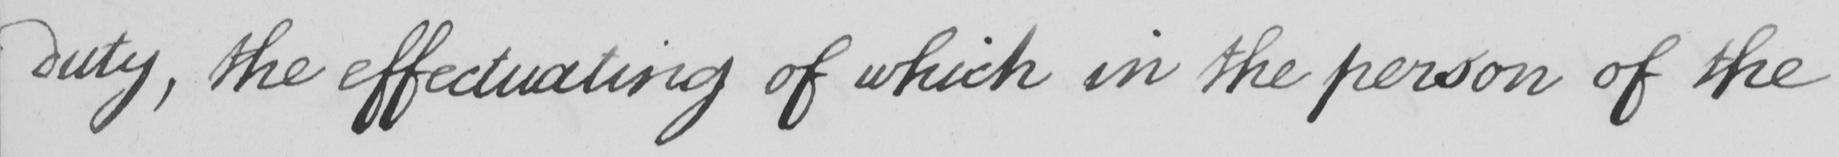What is written in this line of handwriting? duty , the effectuating of which in the person of the 